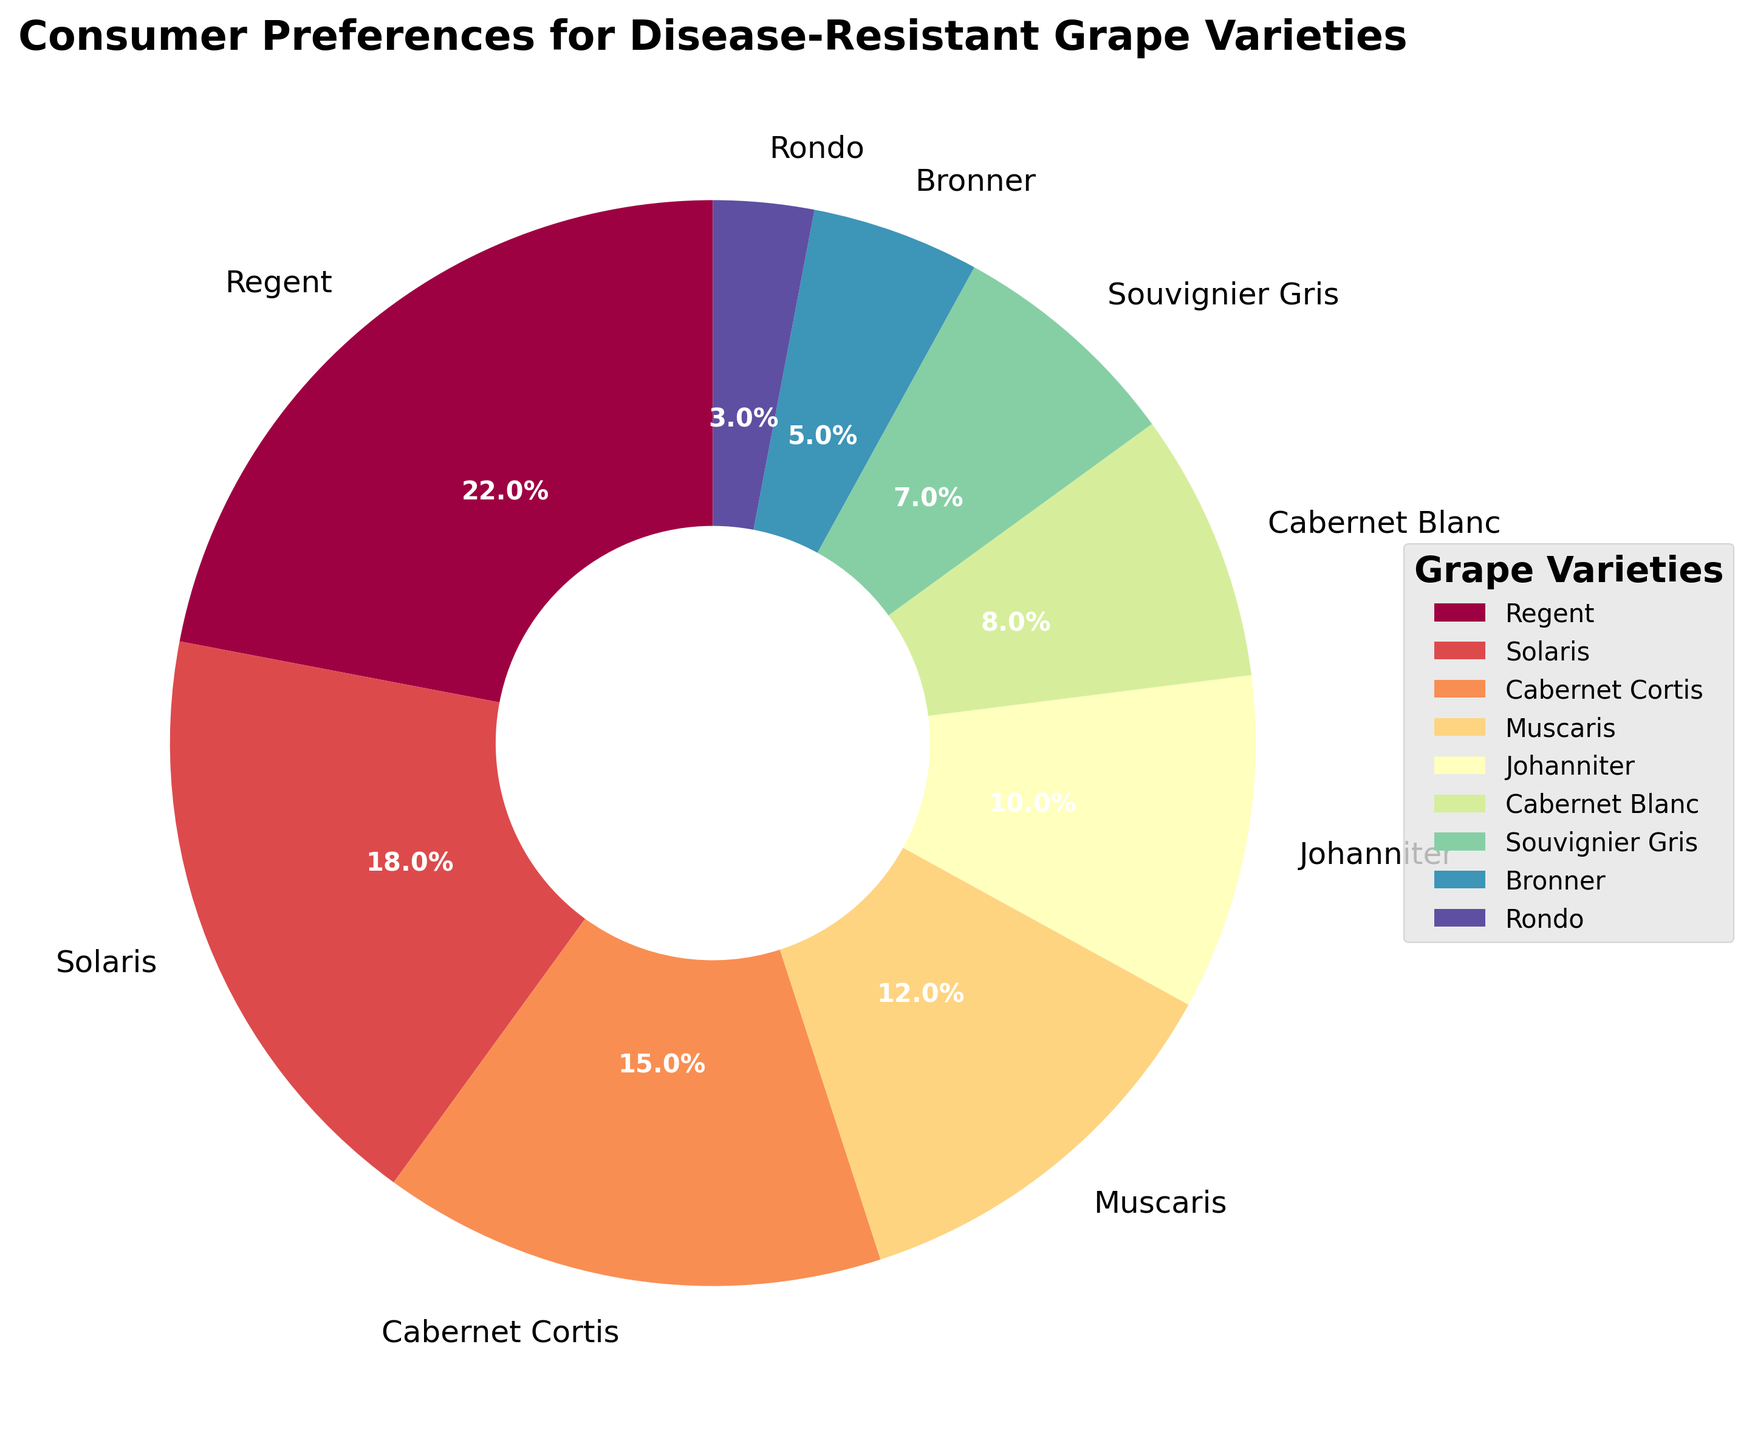What's the most preferred disease-resistant grape variety by consumers? Look at the pie chart and identify the grape variety with the largest wedge. The largest wedge corresponds to Regent, which has a percentage of 22%.
Answer: Regent Which grape varieties have a combined consumer preference percentage of at least 30%? To find the varieties with a combined percentage of at least 30%, start adding the percentages from the largest to smallest until the sum reaches at least 30%. Regent (22%) and Solaris (18%) together sum up to 40%, which meets the criteria.
Answer: Regent, Solaris How much more preferred is Regent compared to Rondo? Calculate the difference in percentages between Regent and Rondo by subtracting Rondo's percentage from Regent’s percentage. Regent is 22% and Rondo is 3%, so the difference is 22% - 3% = 19%.
Answer: 19% What is the average consumer preference percentage for the varieties that prefer less than 10%? Sum the percentages of the varieties that each have less than 10% and divide by the number of those varieties. These varieties are Cabernet Blanc (8%), Souvignier Gris (7%), Bronner (5%), and Rondo (3%), totaling 23%. There are 4 varieties. The average is 23% / 4 = 5.75%.
Answer: 5.75% Is Solaris more preferred than Cabernet Cortis? By how much? Compare the percentages of Solaris and Cabernet Cortis. Solaris has 18% while Cabernet Cortis has 15%. The difference is 18% - 15% = 3%.
Answer: Yes, by 3% Which varieties have consumer preference between 10% and 20%? Identify the wedges that represent percentages between 10% and 20%. These are Solaris (18%), Cabernet Cortis (15%), and Muscaris (12%).
Answer: Solaris, Cabernet Cortis, Muscaris What is the combined consumer preference percentage for Regent, Solaris, and Cabernet Cortis? Sum the percentages of Regent (22%), Solaris (18%), and Cabernet Cortis (15%). The total combined preference is 22% + 18% + 15% = 55%.
Answer: 55% How much more preferred is Solaris compared to Johanniter and Cabernet Blanc combined? Calculate the combined preference for Johanniter and Cabernet Blanc, which is 10% + 8% = 18%. Then, subtract this from Solaris' 18%. Solaris (18%) - Johanniter and Cabernet Blanc combined (18%) = 0%.
Answer: 0% Which grape variety is the least preferred among consumers? Look at the wedge with the smallest percentage. The smallest wedge corresponds to Rondo, which has a percentage of 3%.
Answer: Rondo 